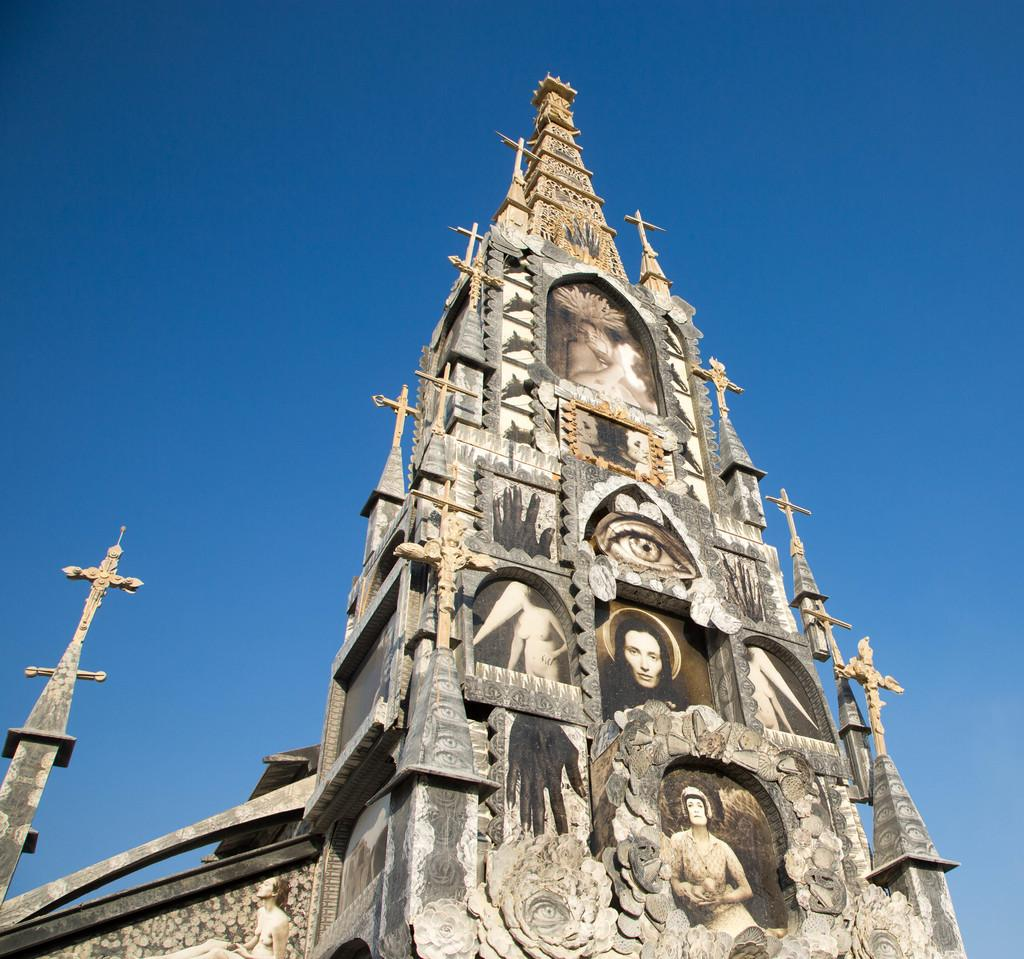What type of building is in the image? There is a church in the image. What can be seen in the background of the image? There is a sky visible in the background of the image. What type of drink is being served in the church in the image? There is no drink being served in the image, as it only features a church and a sky in the background. 